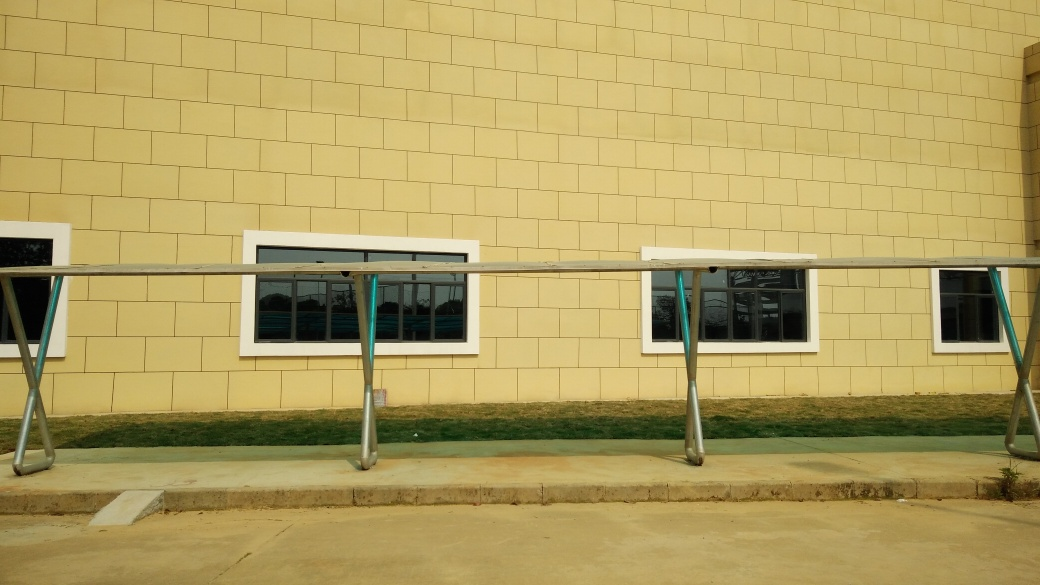What is the overall quality of this image? While the image is clear and well-composed with good lighting, it may be considered average due to the lack of a compelling subject matter, artistic elements or unique perspectives that could elevate its interest. Therefore, the quality is generally good with regards to clarity and exposure, but it doesn't stand out in a significant way. 